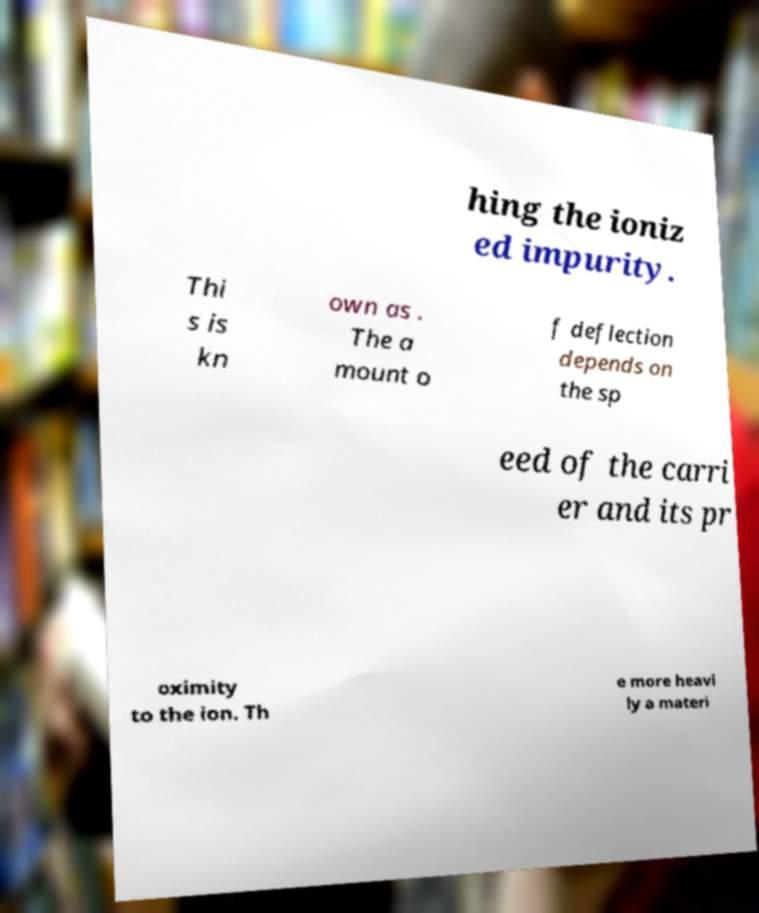Can you read and provide the text displayed in the image?This photo seems to have some interesting text. Can you extract and type it out for me? hing the ioniz ed impurity. Thi s is kn own as . The a mount o f deflection depends on the sp eed of the carri er and its pr oximity to the ion. Th e more heavi ly a materi 